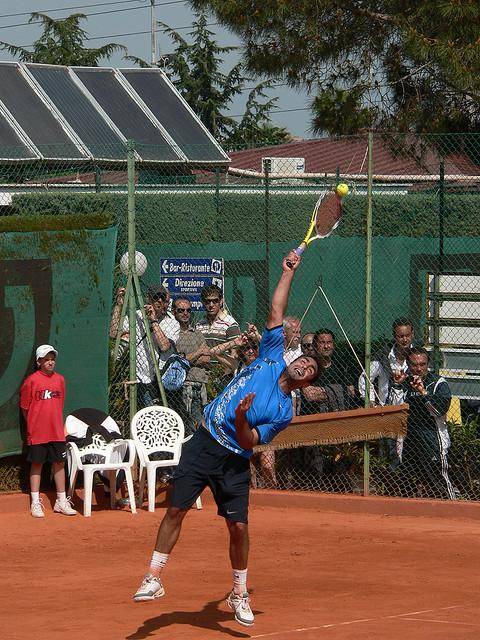What powers the lights here? Please explain your reasoning. solar panels. There are visible solar panels in the top left corner. this is a source of power and happens to be the only one visible. 